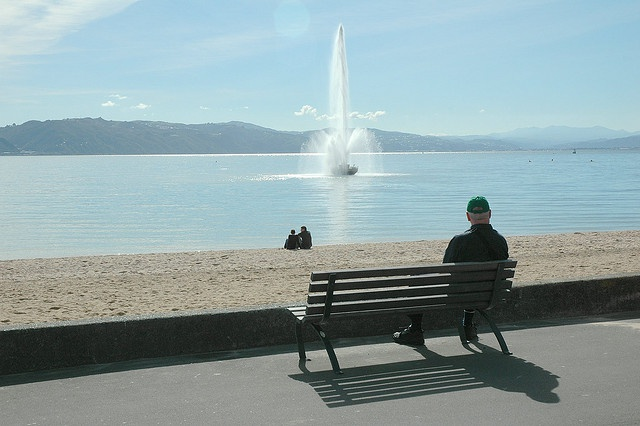Describe the objects in this image and their specific colors. I can see bench in lightgray, black, darkgray, and gray tones, people in lightgray, black, gray, teal, and darkgreen tones, people in lightgray, black, gray, darkgray, and purple tones, and people in lightgray, black, gray, and darkgray tones in this image. 